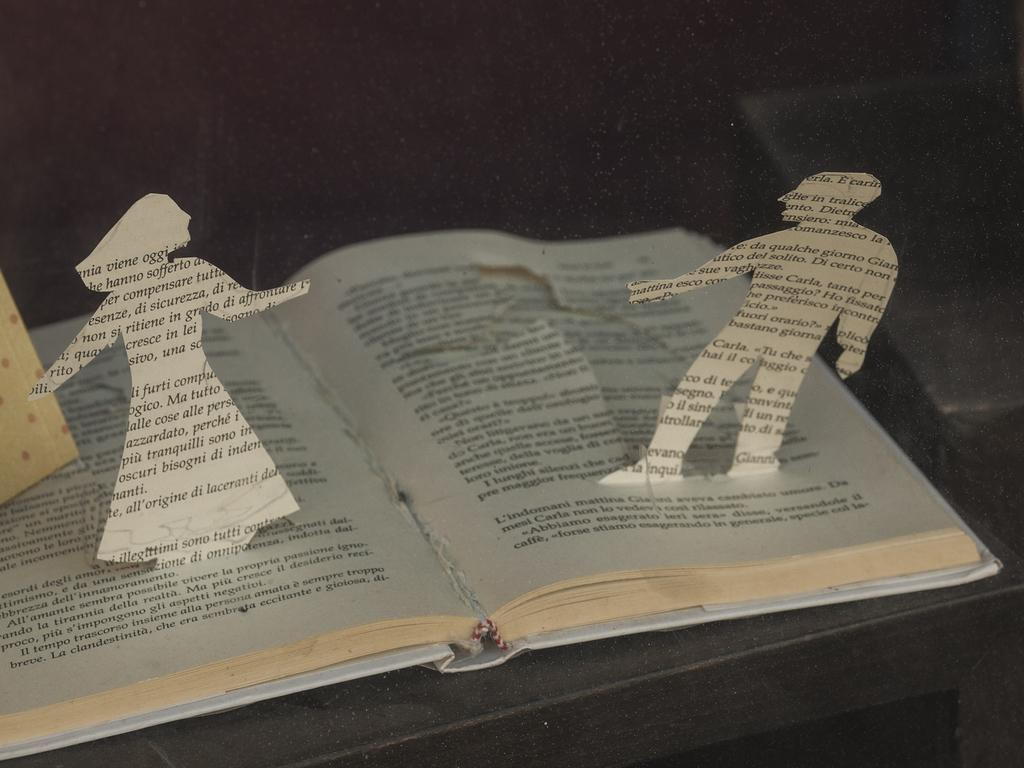<image>
Render a clear and concise summary of the photo. A male and female outline are cut from a book with the male having text about Carla on him. 